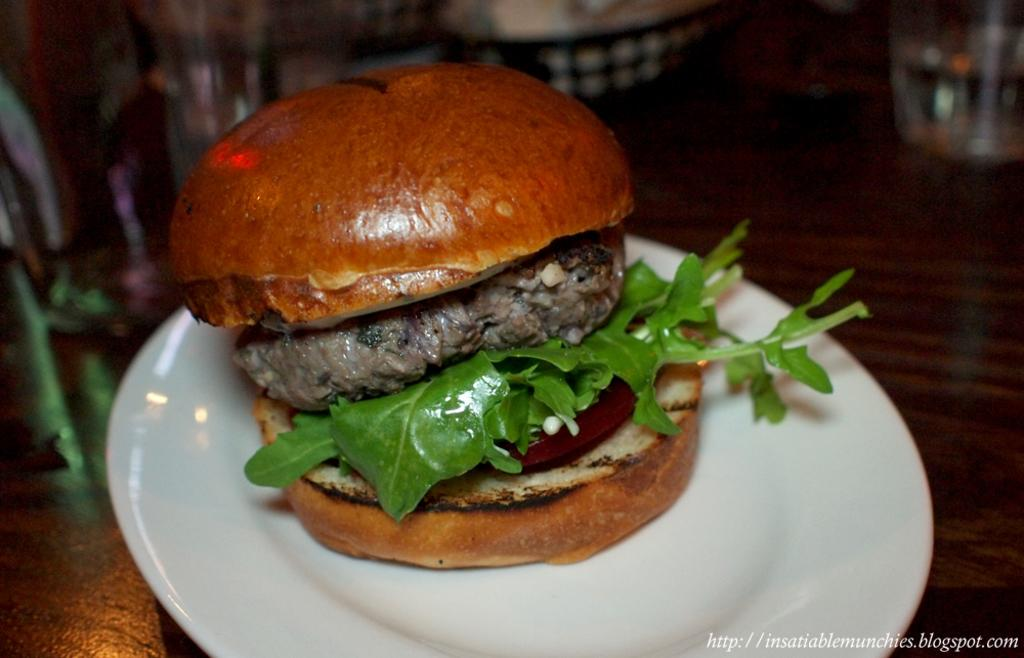What piece of furniture is present in the image? There is a table in the image. What is placed on the table? There is a plate on the table. What is on the plate? The plate contains a burger. What can be seen in the background of the image? There are glasses and other objects visible in the background. What effect does the burger have on the boundary of the table in the image? The burger does not have any effect on the boundary of the table in the image, as it is simply a food item placed on a plate. 